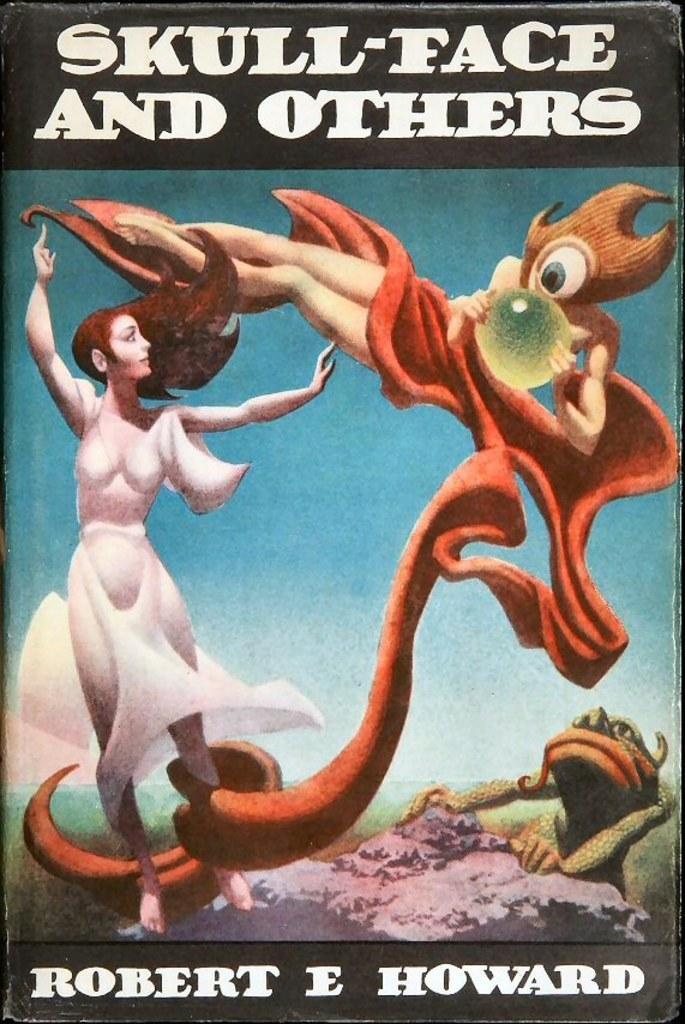Please provide a concise description of this image. This is a poster where we can see one lady is standing and one animal is there on the rock. Top and bottom of the image some text is there. 